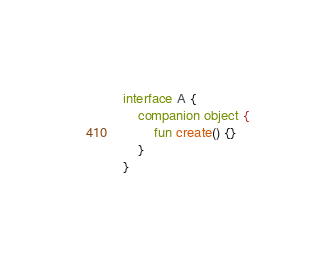<code> <loc_0><loc_0><loc_500><loc_500><_Kotlin_>interface A {
    companion object {
        fun create() {}
    }
}</code> 